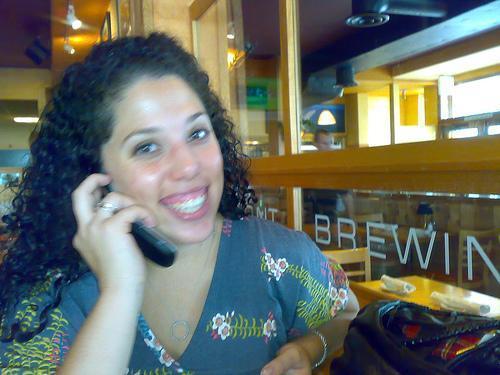How many people can be seen?
Give a very brief answer. 2. How many lights are over the womans head?
Give a very brief answer. 2. 